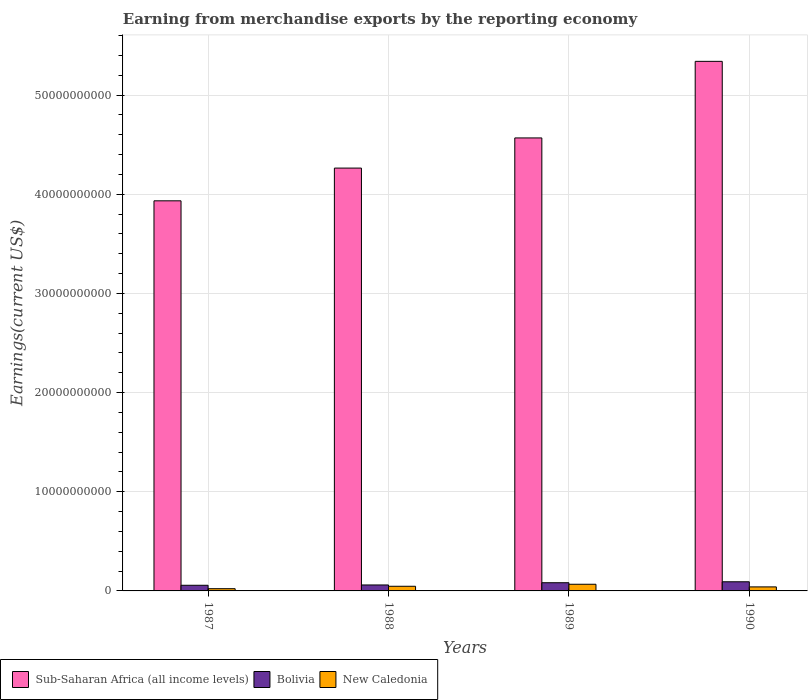Are the number of bars per tick equal to the number of legend labels?
Give a very brief answer. Yes. How many bars are there on the 4th tick from the left?
Your answer should be very brief. 3. In how many cases, is the number of bars for a given year not equal to the number of legend labels?
Keep it short and to the point. 0. What is the amount earned from merchandise exports in New Caledonia in 1987?
Your answer should be very brief. 2.24e+08. Across all years, what is the maximum amount earned from merchandise exports in New Caledonia?
Keep it short and to the point. 6.72e+08. Across all years, what is the minimum amount earned from merchandise exports in Sub-Saharan Africa (all income levels)?
Provide a succinct answer. 3.93e+1. In which year was the amount earned from merchandise exports in Bolivia maximum?
Your answer should be compact. 1990. What is the total amount earned from merchandise exports in Bolivia in the graph?
Give a very brief answer. 2.92e+09. What is the difference between the amount earned from merchandise exports in New Caledonia in 1987 and that in 1989?
Ensure brevity in your answer.  -4.47e+08. What is the difference between the amount earned from merchandise exports in New Caledonia in 1988 and the amount earned from merchandise exports in Bolivia in 1987?
Give a very brief answer. -1.02e+08. What is the average amount earned from merchandise exports in Sub-Saharan Africa (all income levels) per year?
Ensure brevity in your answer.  4.53e+1. In the year 1990, what is the difference between the amount earned from merchandise exports in Sub-Saharan Africa (all income levels) and amount earned from merchandise exports in Bolivia?
Offer a terse response. 5.25e+1. In how many years, is the amount earned from merchandise exports in Sub-Saharan Africa (all income levels) greater than 26000000000 US$?
Ensure brevity in your answer.  4. What is the ratio of the amount earned from merchandise exports in Sub-Saharan Africa (all income levels) in 1987 to that in 1988?
Give a very brief answer. 0.92. What is the difference between the highest and the second highest amount earned from merchandise exports in New Caledonia?
Keep it short and to the point. 2.03e+08. What is the difference between the highest and the lowest amount earned from merchandise exports in New Caledonia?
Your response must be concise. 4.47e+08. In how many years, is the amount earned from merchandise exports in Sub-Saharan Africa (all income levels) greater than the average amount earned from merchandise exports in Sub-Saharan Africa (all income levels) taken over all years?
Your answer should be compact. 2. Is the sum of the amount earned from merchandise exports in Sub-Saharan Africa (all income levels) in 1988 and 1989 greater than the maximum amount earned from merchandise exports in New Caledonia across all years?
Provide a succinct answer. Yes. What does the 1st bar from the left in 1990 represents?
Provide a succinct answer. Sub-Saharan Africa (all income levels). Is it the case that in every year, the sum of the amount earned from merchandise exports in Bolivia and amount earned from merchandise exports in Sub-Saharan Africa (all income levels) is greater than the amount earned from merchandise exports in New Caledonia?
Your response must be concise. Yes. How many years are there in the graph?
Provide a short and direct response. 4. Does the graph contain any zero values?
Ensure brevity in your answer.  No. Does the graph contain grids?
Your response must be concise. Yes. Where does the legend appear in the graph?
Your answer should be compact. Bottom left. How are the legend labels stacked?
Ensure brevity in your answer.  Horizontal. What is the title of the graph?
Ensure brevity in your answer.  Earning from merchandise exports by the reporting economy. Does "Seychelles" appear as one of the legend labels in the graph?
Keep it short and to the point. No. What is the label or title of the Y-axis?
Provide a succinct answer. Earnings(current US$). What is the Earnings(current US$) of Sub-Saharan Africa (all income levels) in 1987?
Your answer should be very brief. 3.93e+1. What is the Earnings(current US$) of Bolivia in 1987?
Make the answer very short. 5.70e+08. What is the Earnings(current US$) of New Caledonia in 1987?
Make the answer very short. 2.24e+08. What is the Earnings(current US$) in Sub-Saharan Africa (all income levels) in 1988?
Offer a very short reply. 4.26e+1. What is the Earnings(current US$) of Bolivia in 1988?
Provide a succinct answer. 6.00e+08. What is the Earnings(current US$) of New Caledonia in 1988?
Ensure brevity in your answer.  4.68e+08. What is the Earnings(current US$) in Sub-Saharan Africa (all income levels) in 1989?
Keep it short and to the point. 4.57e+1. What is the Earnings(current US$) in Bolivia in 1989?
Offer a very short reply. 8.27e+08. What is the Earnings(current US$) of New Caledonia in 1989?
Provide a short and direct response. 6.72e+08. What is the Earnings(current US$) of Sub-Saharan Africa (all income levels) in 1990?
Offer a terse response. 5.34e+1. What is the Earnings(current US$) of Bolivia in 1990?
Give a very brief answer. 9.23e+08. What is the Earnings(current US$) in New Caledonia in 1990?
Offer a very short reply. 4.05e+08. Across all years, what is the maximum Earnings(current US$) of Sub-Saharan Africa (all income levels)?
Give a very brief answer. 5.34e+1. Across all years, what is the maximum Earnings(current US$) in Bolivia?
Give a very brief answer. 9.23e+08. Across all years, what is the maximum Earnings(current US$) of New Caledonia?
Offer a terse response. 6.72e+08. Across all years, what is the minimum Earnings(current US$) in Sub-Saharan Africa (all income levels)?
Offer a very short reply. 3.93e+1. Across all years, what is the minimum Earnings(current US$) in Bolivia?
Your response must be concise. 5.70e+08. Across all years, what is the minimum Earnings(current US$) in New Caledonia?
Offer a terse response. 2.24e+08. What is the total Earnings(current US$) in Sub-Saharan Africa (all income levels) in the graph?
Give a very brief answer. 1.81e+11. What is the total Earnings(current US$) in Bolivia in the graph?
Your response must be concise. 2.92e+09. What is the total Earnings(current US$) of New Caledonia in the graph?
Offer a very short reply. 1.77e+09. What is the difference between the Earnings(current US$) in Sub-Saharan Africa (all income levels) in 1987 and that in 1988?
Offer a very short reply. -3.30e+09. What is the difference between the Earnings(current US$) in Bolivia in 1987 and that in 1988?
Provide a short and direct response. -3.05e+07. What is the difference between the Earnings(current US$) in New Caledonia in 1987 and that in 1988?
Make the answer very short. -2.44e+08. What is the difference between the Earnings(current US$) of Sub-Saharan Africa (all income levels) in 1987 and that in 1989?
Provide a short and direct response. -6.34e+09. What is the difference between the Earnings(current US$) of Bolivia in 1987 and that in 1989?
Keep it short and to the point. -2.57e+08. What is the difference between the Earnings(current US$) in New Caledonia in 1987 and that in 1989?
Provide a short and direct response. -4.47e+08. What is the difference between the Earnings(current US$) in Sub-Saharan Africa (all income levels) in 1987 and that in 1990?
Your response must be concise. -1.41e+1. What is the difference between the Earnings(current US$) of Bolivia in 1987 and that in 1990?
Ensure brevity in your answer.  -3.53e+08. What is the difference between the Earnings(current US$) of New Caledonia in 1987 and that in 1990?
Your answer should be very brief. -1.81e+08. What is the difference between the Earnings(current US$) of Sub-Saharan Africa (all income levels) in 1988 and that in 1989?
Your response must be concise. -3.04e+09. What is the difference between the Earnings(current US$) in Bolivia in 1988 and that in 1989?
Offer a terse response. -2.27e+08. What is the difference between the Earnings(current US$) in New Caledonia in 1988 and that in 1989?
Provide a short and direct response. -2.03e+08. What is the difference between the Earnings(current US$) in Sub-Saharan Africa (all income levels) in 1988 and that in 1990?
Give a very brief answer. -1.08e+1. What is the difference between the Earnings(current US$) in Bolivia in 1988 and that in 1990?
Offer a very short reply. -3.23e+08. What is the difference between the Earnings(current US$) in New Caledonia in 1988 and that in 1990?
Offer a terse response. 6.27e+07. What is the difference between the Earnings(current US$) of Sub-Saharan Africa (all income levels) in 1989 and that in 1990?
Provide a succinct answer. -7.72e+09. What is the difference between the Earnings(current US$) of Bolivia in 1989 and that in 1990?
Provide a succinct answer. -9.60e+07. What is the difference between the Earnings(current US$) of New Caledonia in 1989 and that in 1990?
Your answer should be compact. 2.66e+08. What is the difference between the Earnings(current US$) in Sub-Saharan Africa (all income levels) in 1987 and the Earnings(current US$) in Bolivia in 1988?
Give a very brief answer. 3.87e+1. What is the difference between the Earnings(current US$) of Sub-Saharan Africa (all income levels) in 1987 and the Earnings(current US$) of New Caledonia in 1988?
Your response must be concise. 3.89e+1. What is the difference between the Earnings(current US$) in Bolivia in 1987 and the Earnings(current US$) in New Caledonia in 1988?
Offer a terse response. 1.02e+08. What is the difference between the Earnings(current US$) in Sub-Saharan Africa (all income levels) in 1987 and the Earnings(current US$) in Bolivia in 1989?
Offer a very short reply. 3.85e+1. What is the difference between the Earnings(current US$) in Sub-Saharan Africa (all income levels) in 1987 and the Earnings(current US$) in New Caledonia in 1989?
Your answer should be compact. 3.87e+1. What is the difference between the Earnings(current US$) in Bolivia in 1987 and the Earnings(current US$) in New Caledonia in 1989?
Your response must be concise. -1.02e+08. What is the difference between the Earnings(current US$) in Sub-Saharan Africa (all income levels) in 1987 and the Earnings(current US$) in Bolivia in 1990?
Your answer should be very brief. 3.84e+1. What is the difference between the Earnings(current US$) of Sub-Saharan Africa (all income levels) in 1987 and the Earnings(current US$) of New Caledonia in 1990?
Your response must be concise. 3.89e+1. What is the difference between the Earnings(current US$) of Bolivia in 1987 and the Earnings(current US$) of New Caledonia in 1990?
Your response must be concise. 1.64e+08. What is the difference between the Earnings(current US$) of Sub-Saharan Africa (all income levels) in 1988 and the Earnings(current US$) of Bolivia in 1989?
Ensure brevity in your answer.  4.18e+1. What is the difference between the Earnings(current US$) in Sub-Saharan Africa (all income levels) in 1988 and the Earnings(current US$) in New Caledonia in 1989?
Offer a very short reply. 4.20e+1. What is the difference between the Earnings(current US$) in Bolivia in 1988 and the Earnings(current US$) in New Caledonia in 1989?
Keep it short and to the point. -7.12e+07. What is the difference between the Earnings(current US$) of Sub-Saharan Africa (all income levels) in 1988 and the Earnings(current US$) of Bolivia in 1990?
Give a very brief answer. 4.17e+1. What is the difference between the Earnings(current US$) in Sub-Saharan Africa (all income levels) in 1988 and the Earnings(current US$) in New Caledonia in 1990?
Ensure brevity in your answer.  4.22e+1. What is the difference between the Earnings(current US$) in Bolivia in 1988 and the Earnings(current US$) in New Caledonia in 1990?
Give a very brief answer. 1.95e+08. What is the difference between the Earnings(current US$) of Sub-Saharan Africa (all income levels) in 1989 and the Earnings(current US$) of Bolivia in 1990?
Offer a very short reply. 4.48e+1. What is the difference between the Earnings(current US$) of Sub-Saharan Africa (all income levels) in 1989 and the Earnings(current US$) of New Caledonia in 1990?
Provide a short and direct response. 4.53e+1. What is the difference between the Earnings(current US$) in Bolivia in 1989 and the Earnings(current US$) in New Caledonia in 1990?
Keep it short and to the point. 4.21e+08. What is the average Earnings(current US$) of Sub-Saharan Africa (all income levels) per year?
Provide a short and direct response. 4.53e+1. What is the average Earnings(current US$) of Bolivia per year?
Keep it short and to the point. 7.30e+08. What is the average Earnings(current US$) of New Caledonia per year?
Offer a terse response. 4.42e+08. In the year 1987, what is the difference between the Earnings(current US$) of Sub-Saharan Africa (all income levels) and Earnings(current US$) of Bolivia?
Ensure brevity in your answer.  3.88e+1. In the year 1987, what is the difference between the Earnings(current US$) of Sub-Saharan Africa (all income levels) and Earnings(current US$) of New Caledonia?
Your response must be concise. 3.91e+1. In the year 1987, what is the difference between the Earnings(current US$) of Bolivia and Earnings(current US$) of New Caledonia?
Keep it short and to the point. 3.46e+08. In the year 1988, what is the difference between the Earnings(current US$) of Sub-Saharan Africa (all income levels) and Earnings(current US$) of Bolivia?
Ensure brevity in your answer.  4.20e+1. In the year 1988, what is the difference between the Earnings(current US$) of Sub-Saharan Africa (all income levels) and Earnings(current US$) of New Caledonia?
Your answer should be compact. 4.22e+1. In the year 1988, what is the difference between the Earnings(current US$) in Bolivia and Earnings(current US$) in New Caledonia?
Offer a terse response. 1.32e+08. In the year 1989, what is the difference between the Earnings(current US$) in Sub-Saharan Africa (all income levels) and Earnings(current US$) in Bolivia?
Offer a very short reply. 4.49e+1. In the year 1989, what is the difference between the Earnings(current US$) of Sub-Saharan Africa (all income levels) and Earnings(current US$) of New Caledonia?
Keep it short and to the point. 4.50e+1. In the year 1989, what is the difference between the Earnings(current US$) in Bolivia and Earnings(current US$) in New Caledonia?
Your answer should be very brief. 1.55e+08. In the year 1990, what is the difference between the Earnings(current US$) of Sub-Saharan Africa (all income levels) and Earnings(current US$) of Bolivia?
Give a very brief answer. 5.25e+1. In the year 1990, what is the difference between the Earnings(current US$) in Sub-Saharan Africa (all income levels) and Earnings(current US$) in New Caledonia?
Make the answer very short. 5.30e+1. In the year 1990, what is the difference between the Earnings(current US$) of Bolivia and Earnings(current US$) of New Caledonia?
Ensure brevity in your answer.  5.18e+08. What is the ratio of the Earnings(current US$) of Sub-Saharan Africa (all income levels) in 1987 to that in 1988?
Your answer should be compact. 0.92. What is the ratio of the Earnings(current US$) of Bolivia in 1987 to that in 1988?
Make the answer very short. 0.95. What is the ratio of the Earnings(current US$) of New Caledonia in 1987 to that in 1988?
Offer a very short reply. 0.48. What is the ratio of the Earnings(current US$) of Sub-Saharan Africa (all income levels) in 1987 to that in 1989?
Keep it short and to the point. 0.86. What is the ratio of the Earnings(current US$) of Bolivia in 1987 to that in 1989?
Your response must be concise. 0.69. What is the ratio of the Earnings(current US$) in New Caledonia in 1987 to that in 1989?
Ensure brevity in your answer.  0.33. What is the ratio of the Earnings(current US$) in Sub-Saharan Africa (all income levels) in 1987 to that in 1990?
Your answer should be very brief. 0.74. What is the ratio of the Earnings(current US$) of Bolivia in 1987 to that in 1990?
Ensure brevity in your answer.  0.62. What is the ratio of the Earnings(current US$) in New Caledonia in 1987 to that in 1990?
Your answer should be very brief. 0.55. What is the ratio of the Earnings(current US$) of Sub-Saharan Africa (all income levels) in 1988 to that in 1989?
Provide a succinct answer. 0.93. What is the ratio of the Earnings(current US$) of Bolivia in 1988 to that in 1989?
Offer a terse response. 0.73. What is the ratio of the Earnings(current US$) of New Caledonia in 1988 to that in 1989?
Keep it short and to the point. 0.7. What is the ratio of the Earnings(current US$) in Sub-Saharan Africa (all income levels) in 1988 to that in 1990?
Your answer should be compact. 0.8. What is the ratio of the Earnings(current US$) of Bolivia in 1988 to that in 1990?
Your answer should be very brief. 0.65. What is the ratio of the Earnings(current US$) of New Caledonia in 1988 to that in 1990?
Offer a terse response. 1.15. What is the ratio of the Earnings(current US$) in Sub-Saharan Africa (all income levels) in 1989 to that in 1990?
Ensure brevity in your answer.  0.86. What is the ratio of the Earnings(current US$) of Bolivia in 1989 to that in 1990?
Ensure brevity in your answer.  0.9. What is the ratio of the Earnings(current US$) of New Caledonia in 1989 to that in 1990?
Keep it short and to the point. 1.66. What is the difference between the highest and the second highest Earnings(current US$) in Sub-Saharan Africa (all income levels)?
Offer a terse response. 7.72e+09. What is the difference between the highest and the second highest Earnings(current US$) in Bolivia?
Offer a very short reply. 9.60e+07. What is the difference between the highest and the second highest Earnings(current US$) of New Caledonia?
Give a very brief answer. 2.03e+08. What is the difference between the highest and the lowest Earnings(current US$) in Sub-Saharan Africa (all income levels)?
Provide a short and direct response. 1.41e+1. What is the difference between the highest and the lowest Earnings(current US$) in Bolivia?
Make the answer very short. 3.53e+08. What is the difference between the highest and the lowest Earnings(current US$) of New Caledonia?
Provide a short and direct response. 4.47e+08. 